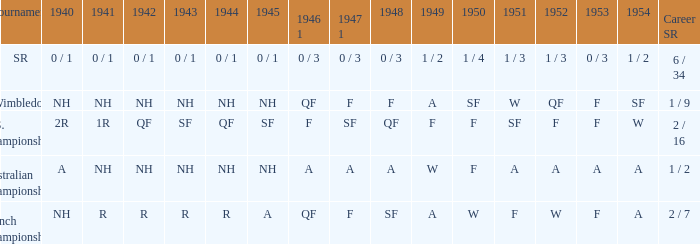What is the 1944 result for the U.S. Championships? QF. 